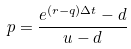Convert formula to latex. <formula><loc_0><loc_0><loc_500><loc_500>p = \frac { e ^ { ( r - q ) \Delta t } - d } { u - d }</formula> 